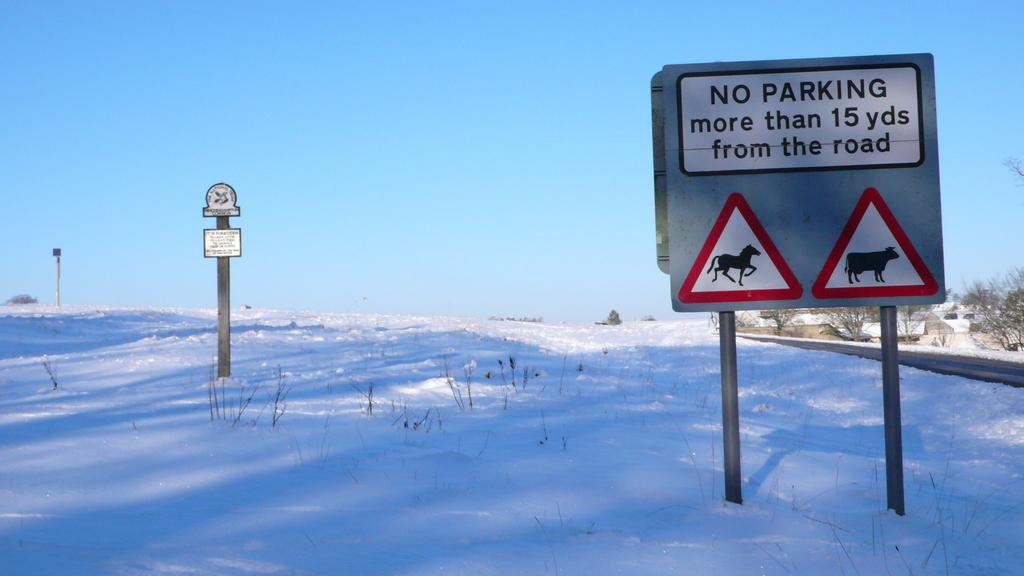<image>
Provide a brief description of the given image. A sign states that people must not park more than 15 yards from the road. 